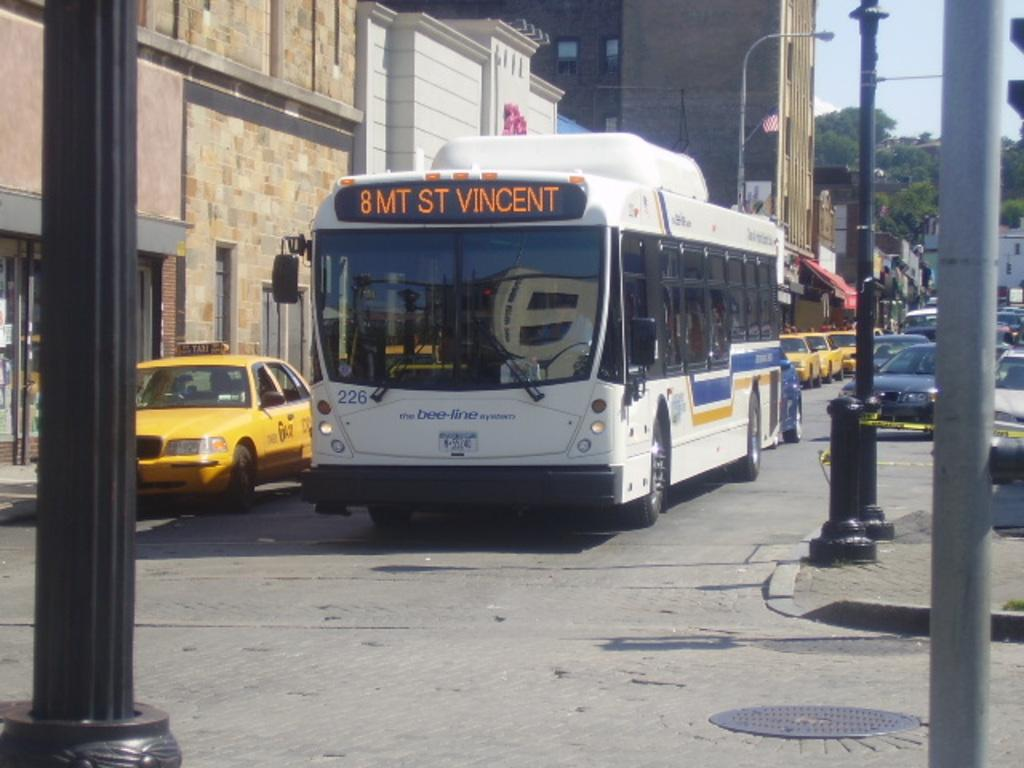<image>
Create a compact narrative representing the image presented. A white transit bus displaying the address 8 MT ST Vincent. 